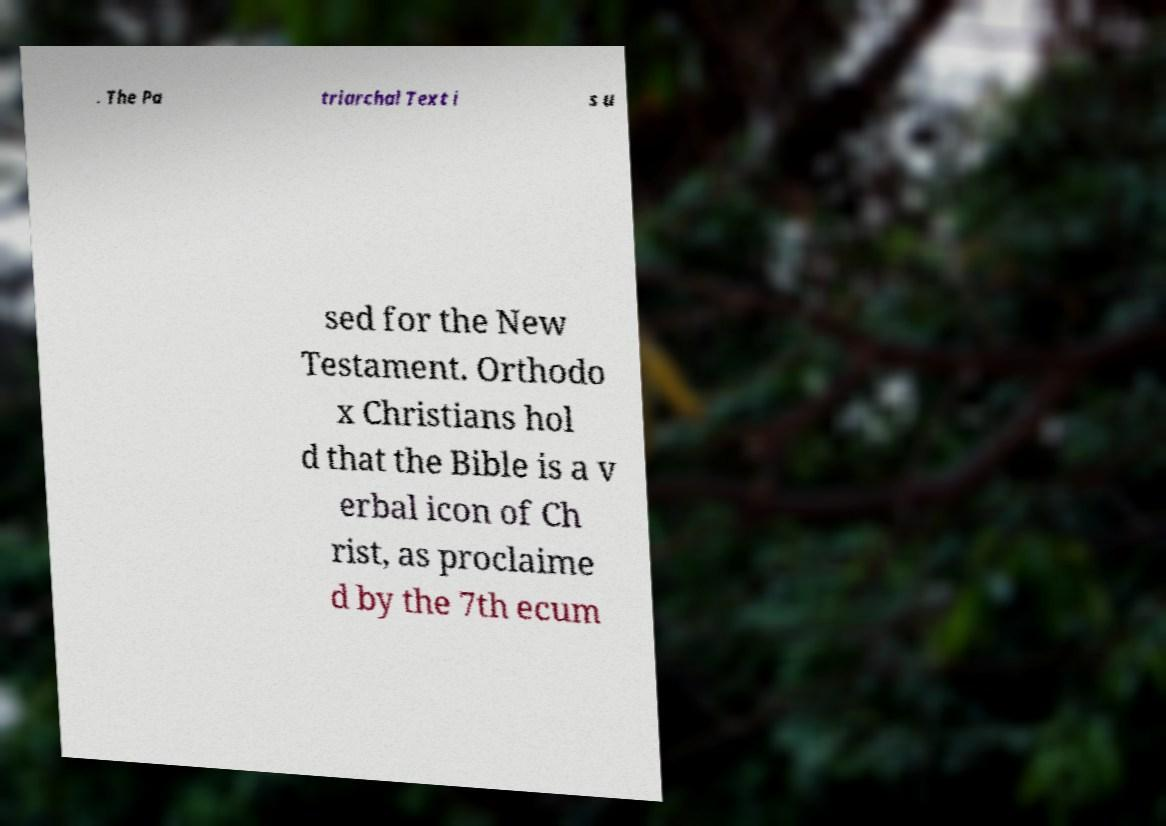I need the written content from this picture converted into text. Can you do that? . The Pa triarchal Text i s u sed for the New Testament. Orthodo x Christians hol d that the Bible is a v erbal icon of Ch rist, as proclaime d by the 7th ecum 